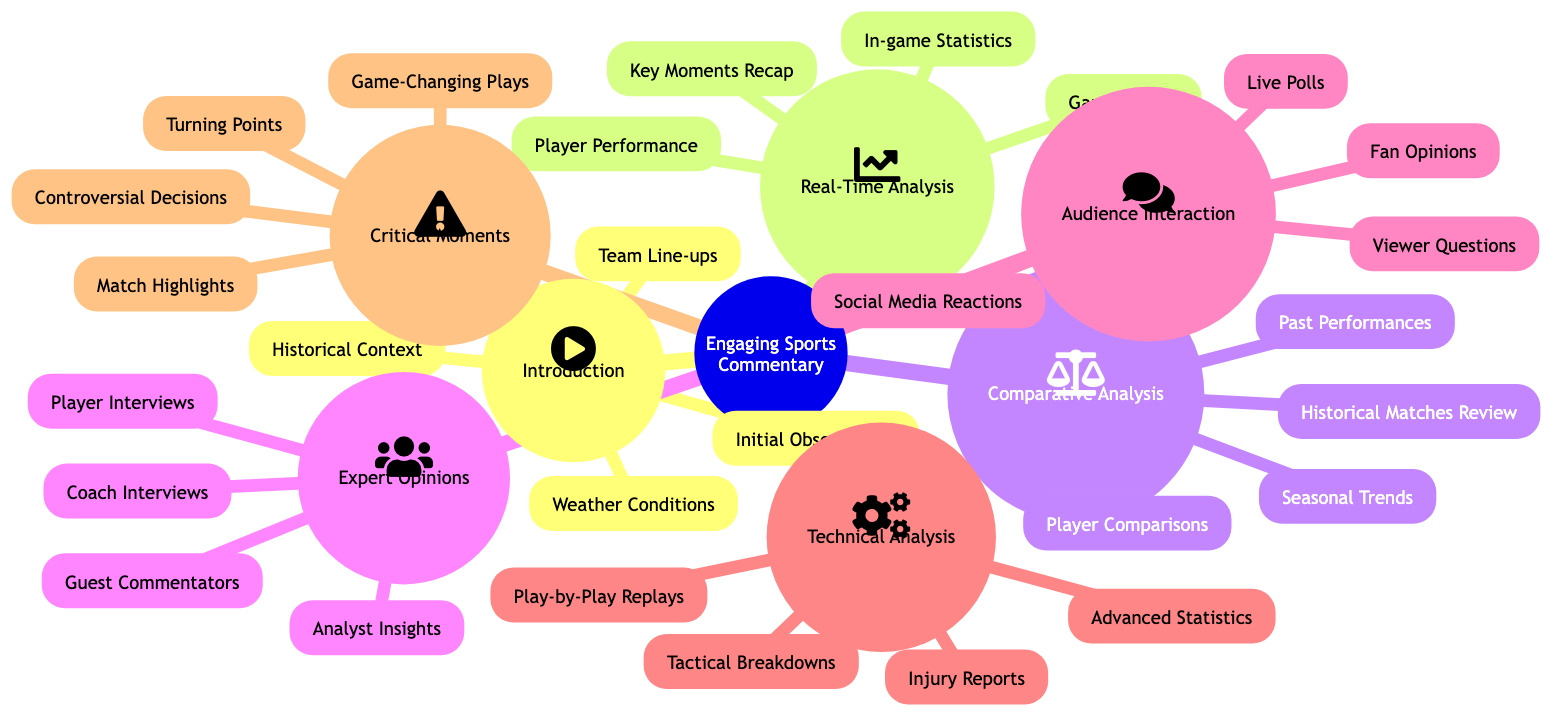What are the main categories of engaging sports commentary? The diagram presents seven main categories: Introduction, Real-Time Analysis, Comparative Analysis, Expert Opinions, Audience Interaction, Technical Analysis, and Critical Moments.
Answer: Seven What are the elements listed under Expert Opinions? The Expert Opinions category includes four elements: Guest Commentators, Coach Interviews, Player Interviews, and Analyst Insights.
Answer: Guest Commentators, Coach Interviews, Player Interviews, Analyst Insights Which category includes Tactical Breakdowns? Tactical Breakdowns is an element within the Technical Analysis category.
Answer: Technical Analysis How many elements are there under Audience Interaction? The Audience Interaction section has four elements: Social Media Reactions, Live Polls, Viewer Questions, and Fan Opinions, totaling four elements.
Answer: Four Which category is focused on live insights? The Real-Time Analysis category focuses on live insights that keep the audience engaged and informed.
Answer: Real-Time Analysis What type of analysis does the Comparative Analysis section provide? The Comparative Analysis section provides depth by drawing comparisons with past performances or similar matches.
Answer: Depth Which elements are considered critical moments in a game? The Critical Moments section highlights Turning Points, Game-Changing Plays, Controversial Decisions, and Match Highlights as critical moments.
Answer: Turning Points, Game-Changing Plays, Controversial Decisions, Match Highlights How many sections are there dedicated to audience engagement? There are two sections dedicated to audience engagement: Audience Interaction and Real-Time Analysis, making a total of two sections.
Answer: Two What describes the Technical Analysis category? The Technical Analysis category provides an in-depth look at the technical aspects of the game for a knowledgeable audience.
Answer: In-depth look at technical aspects 